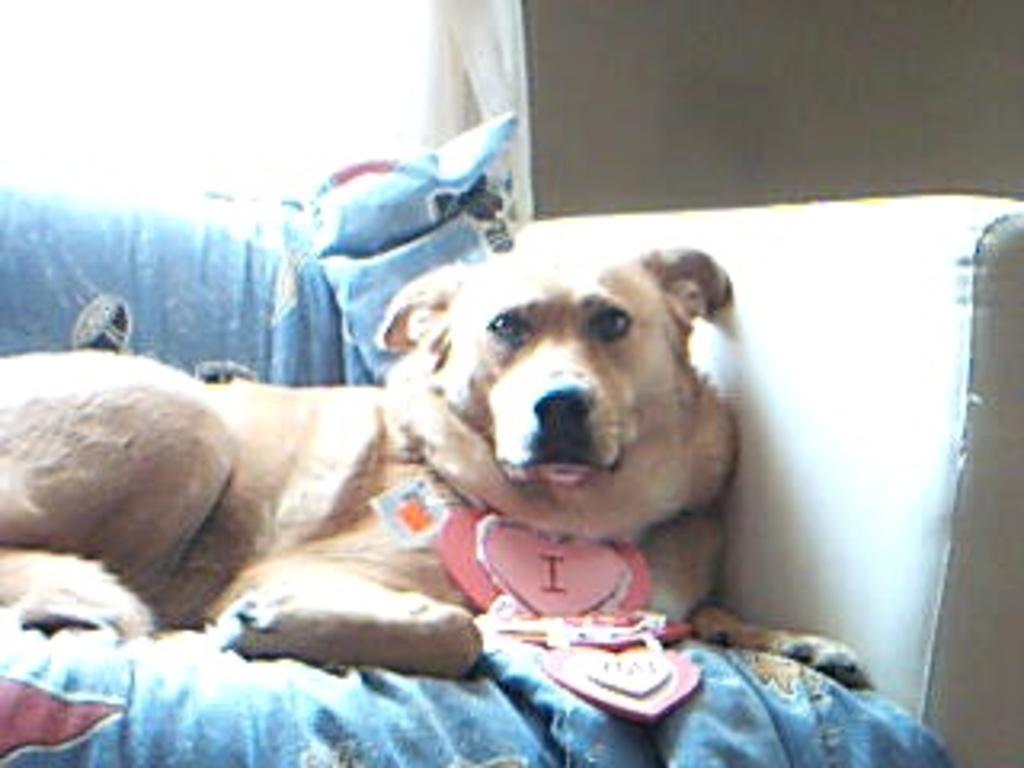In one or two sentences, can you explain what this image depicts? A dog is sitting on the sofa, there is cloth. 